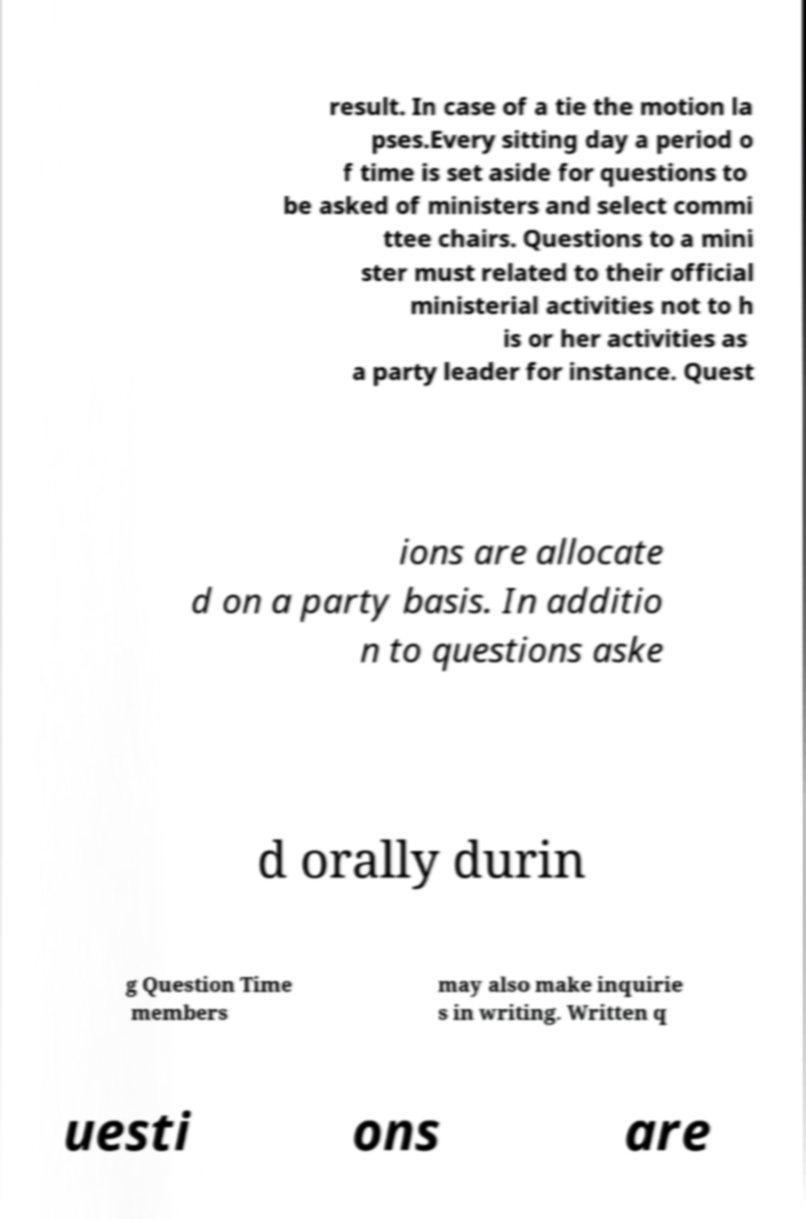Can you read and provide the text displayed in the image?This photo seems to have some interesting text. Can you extract and type it out for me? result. In case of a tie the motion la pses.Every sitting day a period o f time is set aside for questions to be asked of ministers and select commi ttee chairs. Questions to a mini ster must related to their official ministerial activities not to h is or her activities as a party leader for instance. Quest ions are allocate d on a party basis. In additio n to questions aske d orally durin g Question Time members may also make inquirie s in writing. Written q uesti ons are 